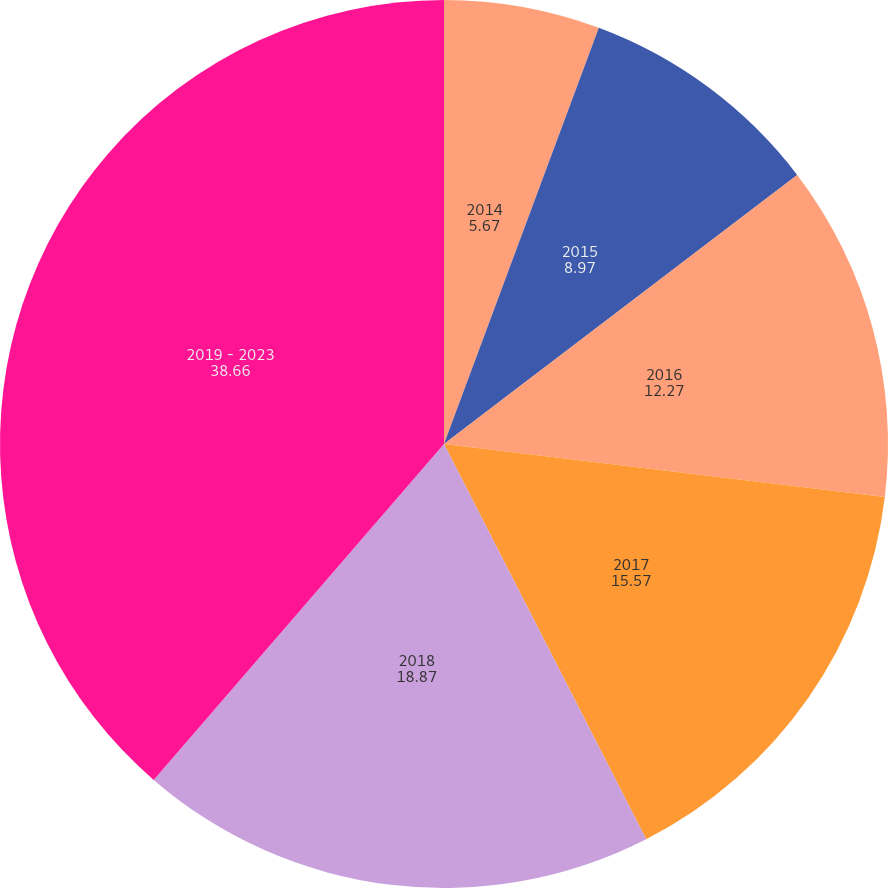Convert chart to OTSL. <chart><loc_0><loc_0><loc_500><loc_500><pie_chart><fcel>2014<fcel>2015<fcel>2016<fcel>2017<fcel>2018<fcel>2019 - 2023<nl><fcel>5.67%<fcel>8.97%<fcel>12.27%<fcel>15.57%<fcel>18.87%<fcel>38.66%<nl></chart> 